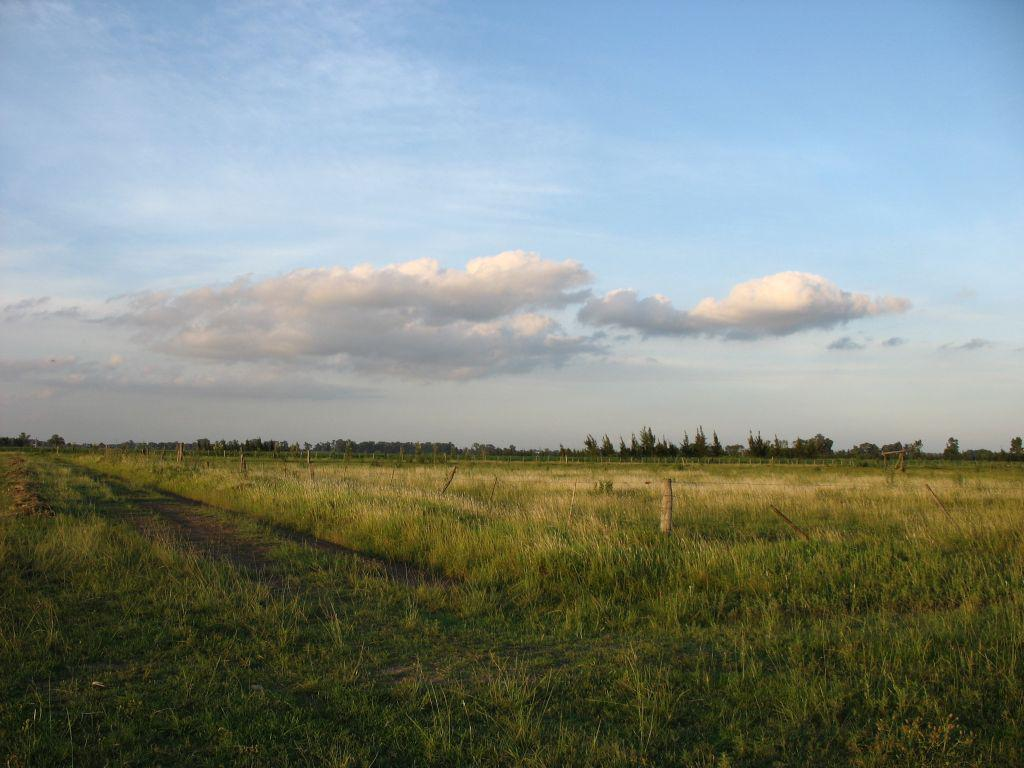What type of vegetation is at the bottom of the image? There is grass at the bottom of the image. What can be seen in the background of the image? There are trees in the background of the image. What is visible at the top of the image? The sky is visible at the top of the image. What type of jeans is the group wearing in the image? There is no group or jeans present in the image; it features grass, trees, and the sky. What pet can be seen playing with a ball in the image? There is no pet or ball present in the image. 